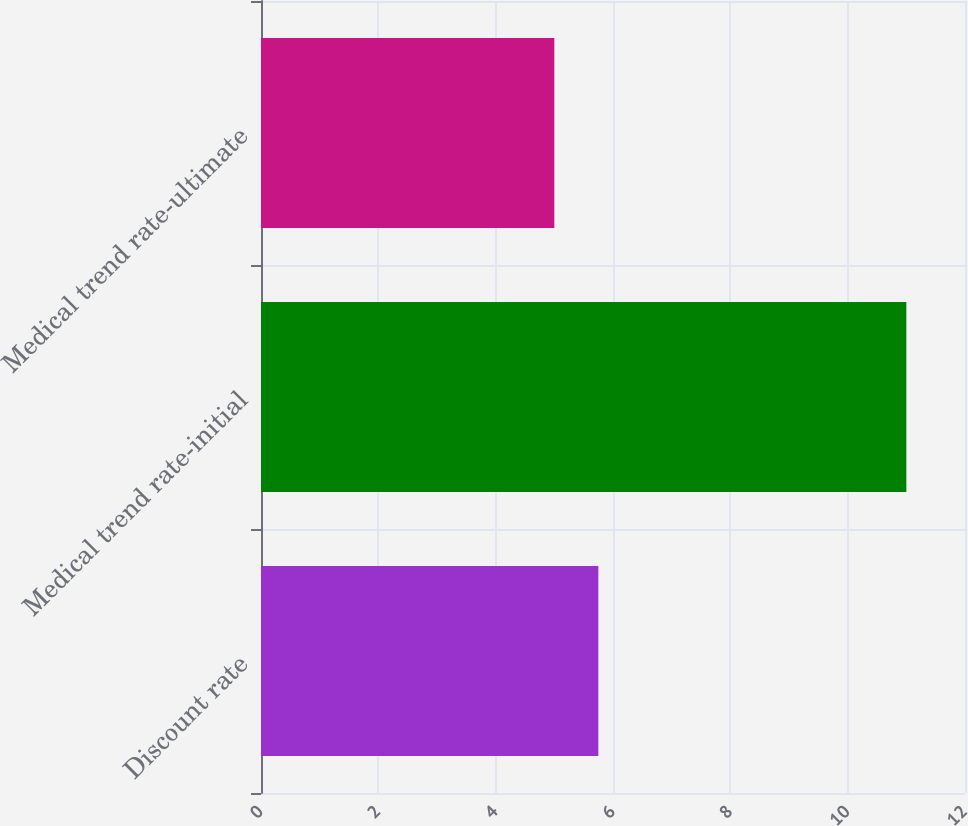Convert chart to OTSL. <chart><loc_0><loc_0><loc_500><loc_500><bar_chart><fcel>Discount rate<fcel>Medical trend rate-initial<fcel>Medical trend rate-ultimate<nl><fcel>5.75<fcel>11<fcel>5<nl></chart> 